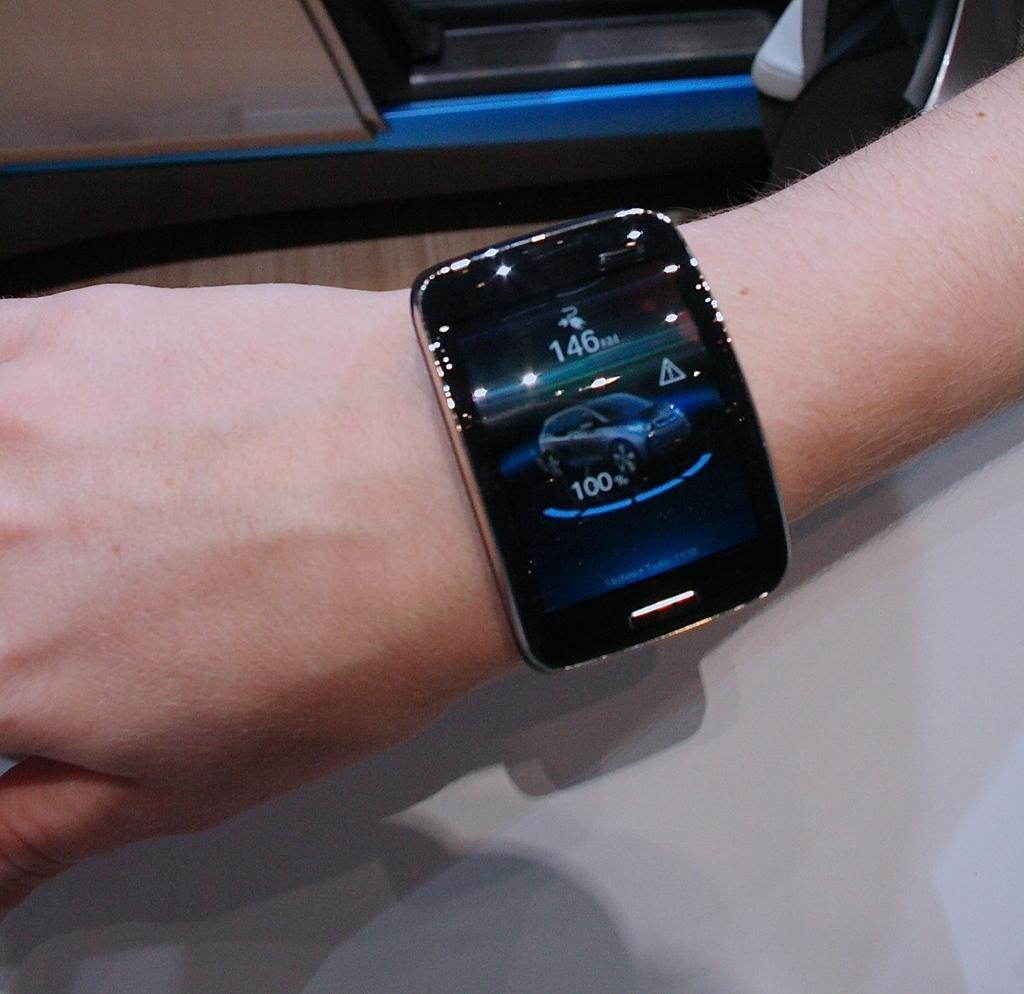<image>
Relay a brief, clear account of the picture shown. A person's watch shows an image of a car and the numbers 146 and 100. 